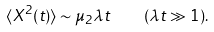<formula> <loc_0><loc_0><loc_500><loc_500>\langle X ^ { 2 } ( t ) \rangle \sim \mu _ { 2 } \lambda t \quad ( \lambda t \gg 1 ) .</formula> 